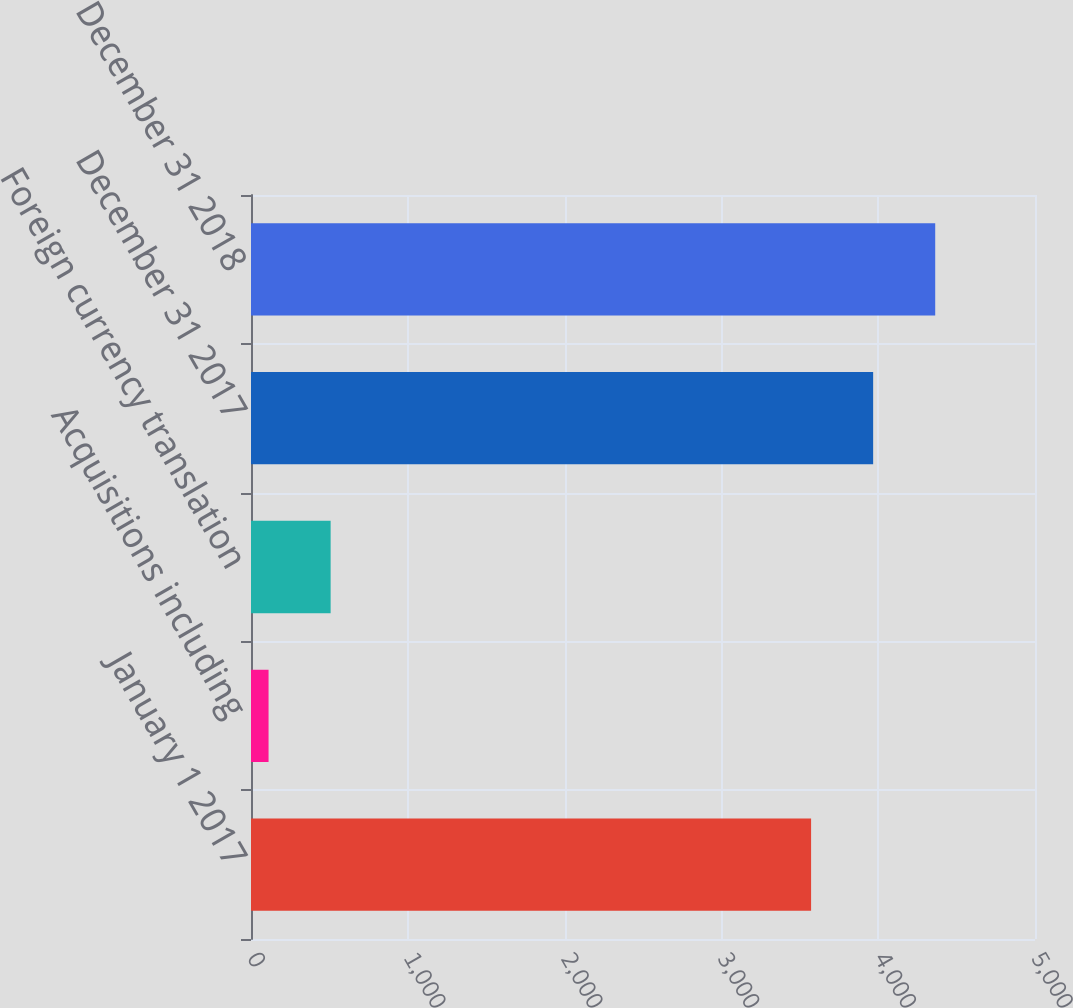Convert chart. <chart><loc_0><loc_0><loc_500><loc_500><bar_chart><fcel>January 1 2017<fcel>Acquisitions including<fcel>Foreign currency translation<fcel>December 31 2017<fcel>December 31 2018<nl><fcel>3572<fcel>112<fcel>507.8<fcel>3967.8<fcel>4363.6<nl></chart> 